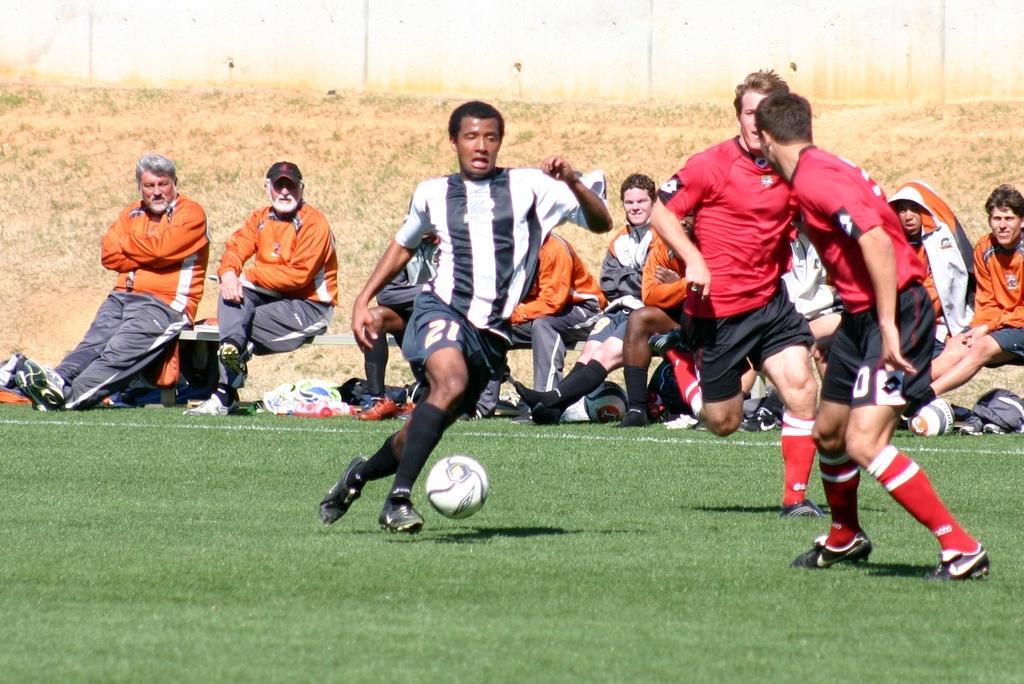Describe this image in one or two sentences. This image is clicked in a ground. There are some persons sitting on benches. There are 3 persons in the middle, who are playing. There is a ball in the middle. 